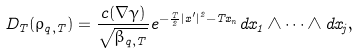Convert formula to latex. <formula><loc_0><loc_0><loc_500><loc_500>D _ { T } ( \rho _ { q , T } ) = \frac { c ( \nabla \gamma ) } { \sqrt { \beta _ { q , T } } } e ^ { - \frac { T } { 2 } | x ^ { \prime } | ^ { 2 } - T x _ { n } } d x _ { 1 } \wedge \dots \wedge d x _ { j } ,</formula> 